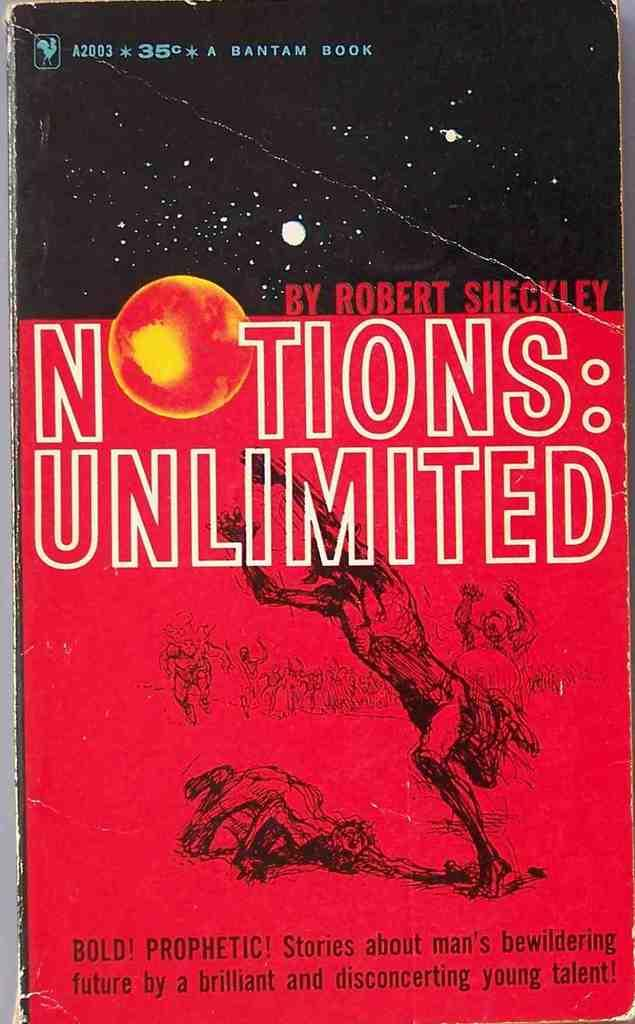<image>
Offer a succinct explanation of the picture presented. A Bantam Book by the name of NOTIONS:UNLIMITED BY ROBERT SHECKLEY is pictured. 